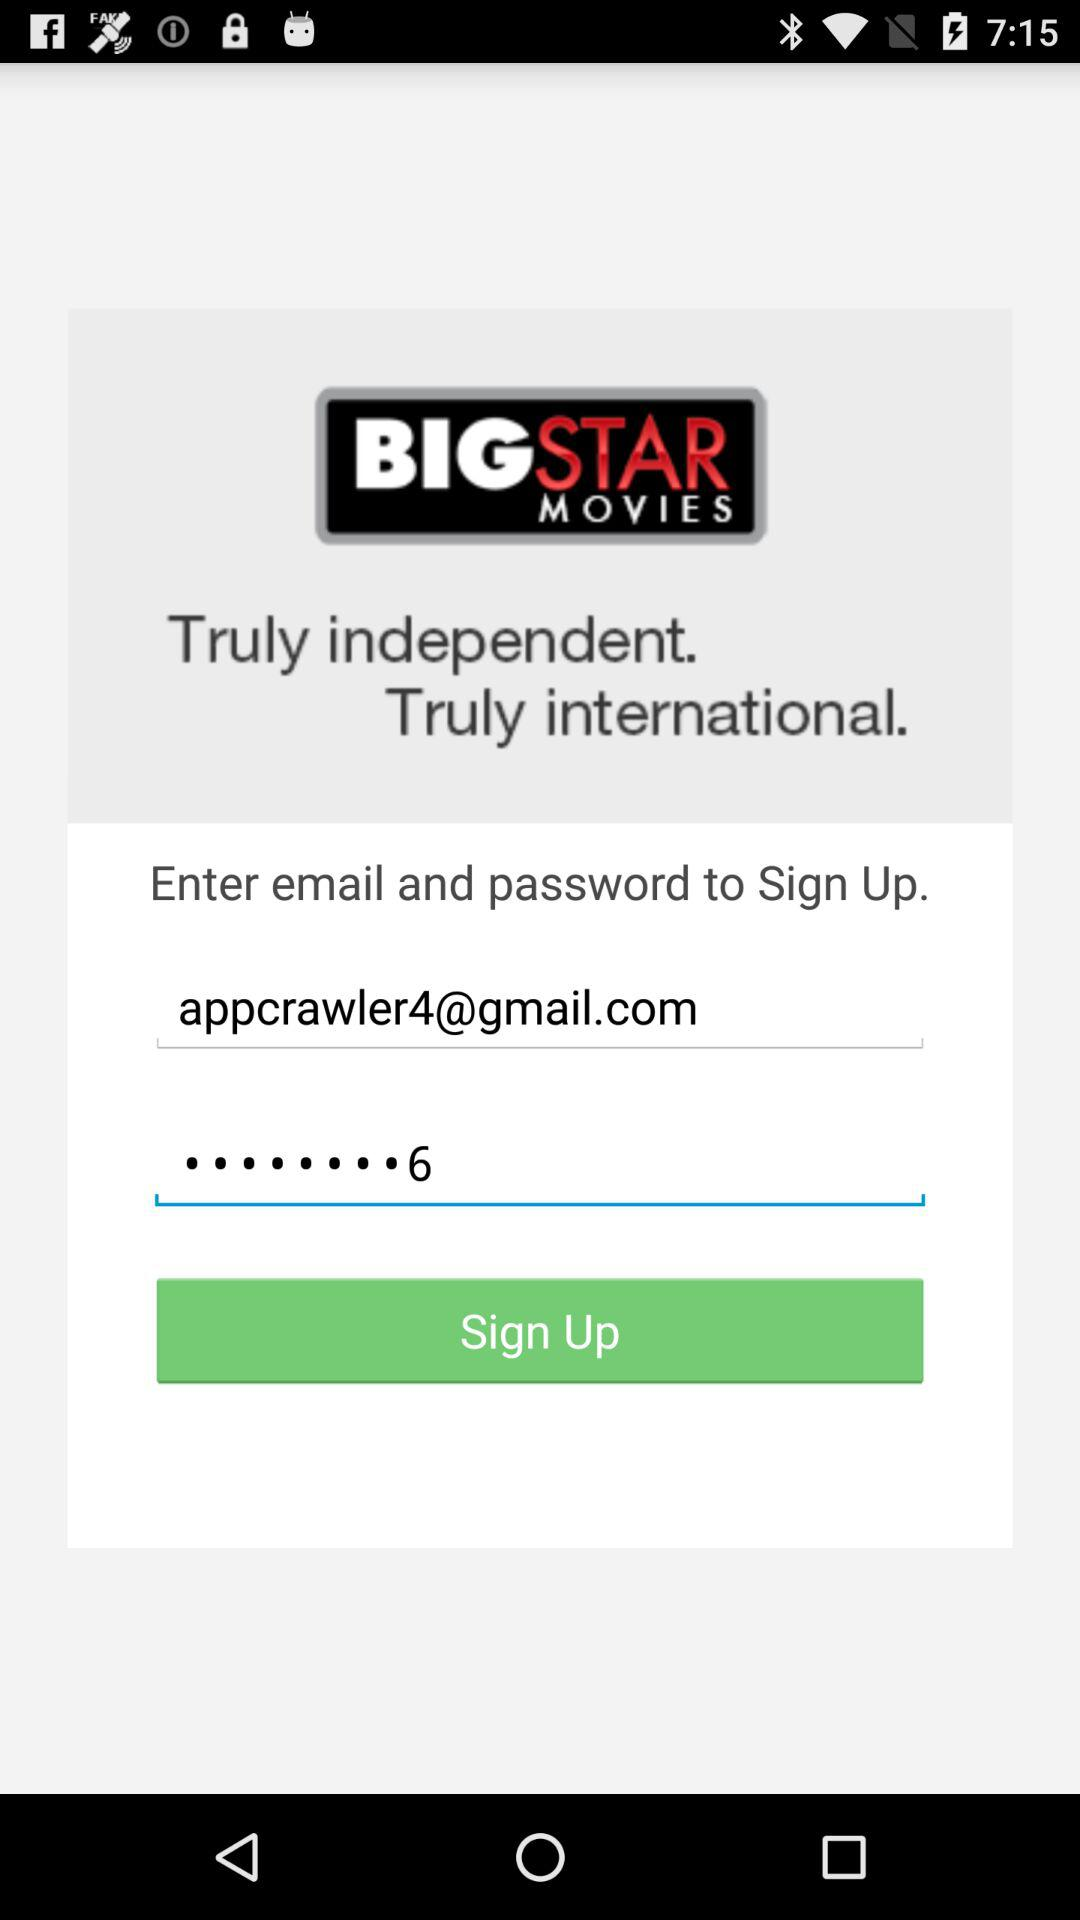What are the requirements to sign up? The requirements to sign up are an email address and a password. 